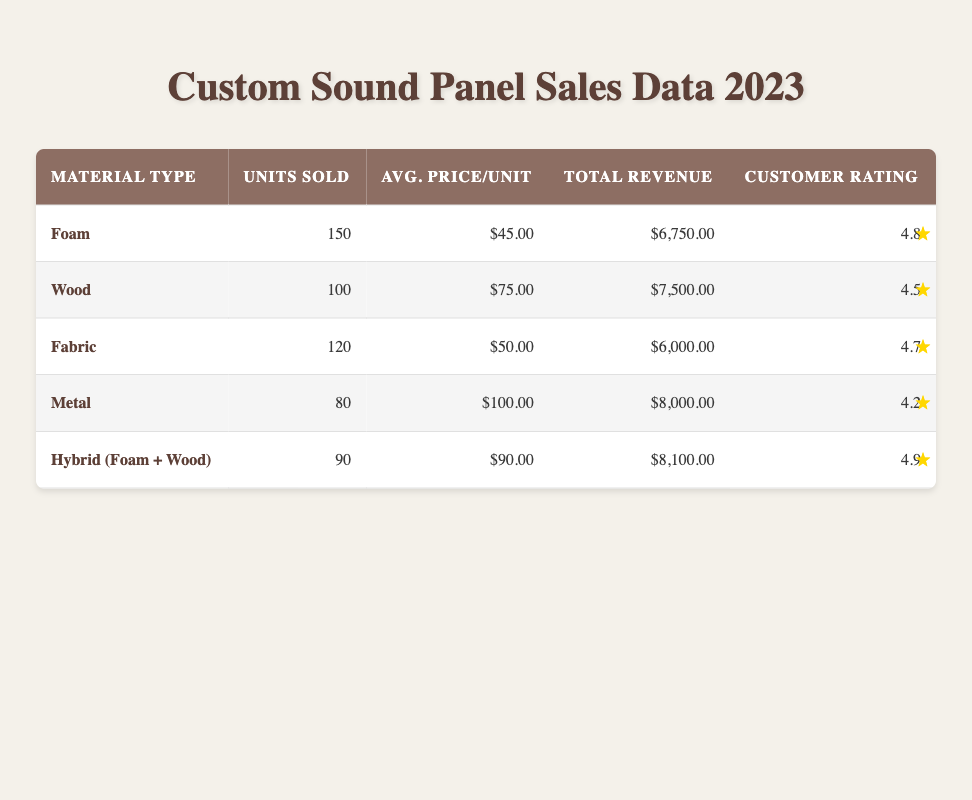What is the total revenue generated from Foam sound panels? The total revenue for Foam sound panels is specifically listed in the table under the "Total Revenue" column. It shows $6,750.00 for this material type.
Answer: $6,750.00 Which material type had the highest customer feedback rating? By examining the "Customer Rating" column, we can determine which material type has the highest value. Hybrid (Foam + Wood) has a rating of 4.9, which is higher than any other material type.
Answer: Hybrid (Foam + Wood) How many units were sold in total across all material types? We need to sum the "Units Sold" values for each material type: 150 (Foam) + 100 (Wood) + 120 (Fabric) + 80 (Metal) + 90 (Hybrid) = 540.
Answer: 540 What is the average price per unit for all sound panels? We calculate the average price by summing the total average prices for each material type and dividing by the number of types: (45 + 75 + 50 + 100 + 90) / 5 = 72.
Answer: 72 Is the total revenue from Metal sound panels greater than that from Fabric panels? Looking at the "Total Revenue" values: Metal shows $8,000.00, while Fabric shows $6,000.00. Since $8,000.00 is greater than $6,000.00, the statement is true.
Answer: Yes Which material type had the lowest units sold, and what was the count? To find the lowest, we compare the "Units Sold" of each material. The lowest is Metal with 80 units sold.
Answer: Metal, 80 If we were to rank the material types based on their average price per unit, which would be in the top three? First, we need to list the average prices: Foam ($45), Wood ($75), Fabric ($50), Metal ($100), Hybrid ($90). The top three are Metal ($100), Hybrid ($90), and Wood ($75).
Answer: Metal, Hybrid, Wood How much total revenue was generated from Foam and Fabric combined? We will add the total revenues: Foam is $6,750.00 and Fabric is $6,000.00. Thus, $6,750.00 + $6,000.00 = $12,750.00 in total revenue from both.
Answer: $12,750.00 Is the average customer feedback rating for Fabric panels higher than 4.5? The feedback rating for Fabric is 4.7, which is indeed greater than 4.5. This confirms the statement is true.
Answer: Yes 